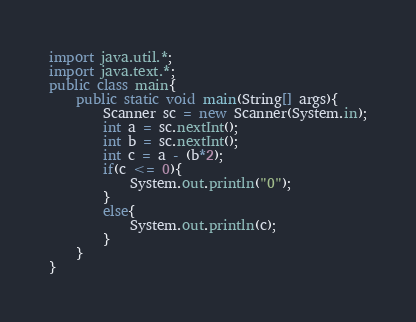<code> <loc_0><loc_0><loc_500><loc_500><_Java_>import java.util.*;
import java.text.*;
public class main{
	public static void main(String[] args){
		Scanner sc = new Scanner(System.in);
		int a = sc.nextInt();
		int b = sc.nextInt();
		int c = a - (b*2);
		if(c <= 0){
			System.out.println("0");
		}
		else{
			System.out.println(c);
		}
	}
}</code> 